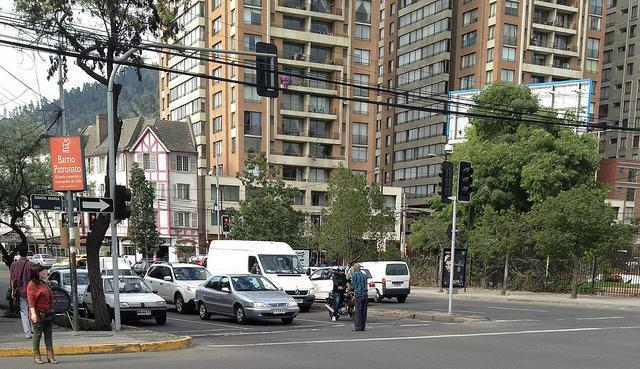What color is the curb on the left painted?
Answer briefly. Yellow. Do the cars have yellow license plates?
Give a very brief answer. No. How many people are there?
Give a very brief answer. 4. Is the Main Street in the foreground a two-way street?
Be succinct. Yes. 